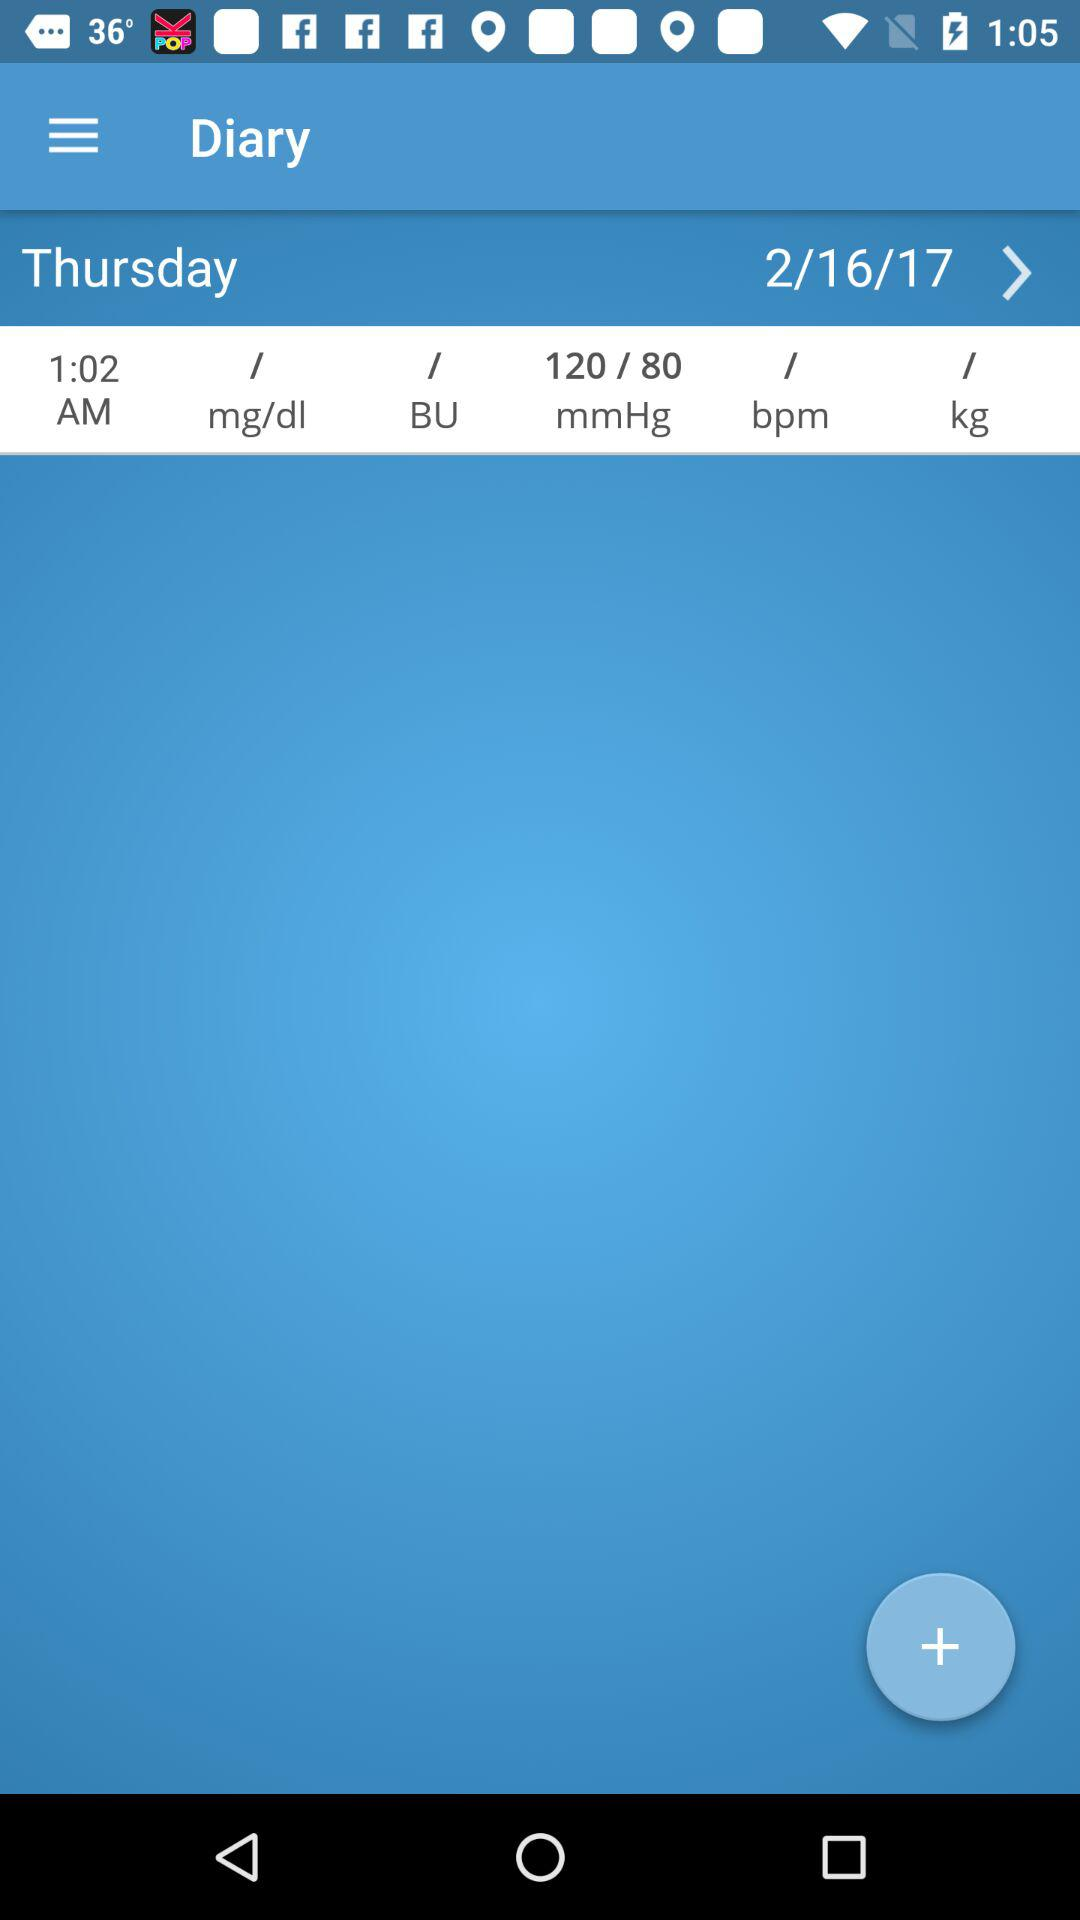What is the difference between the systolic and diastolic blood pressure?
Answer the question using a single word or phrase. 40 